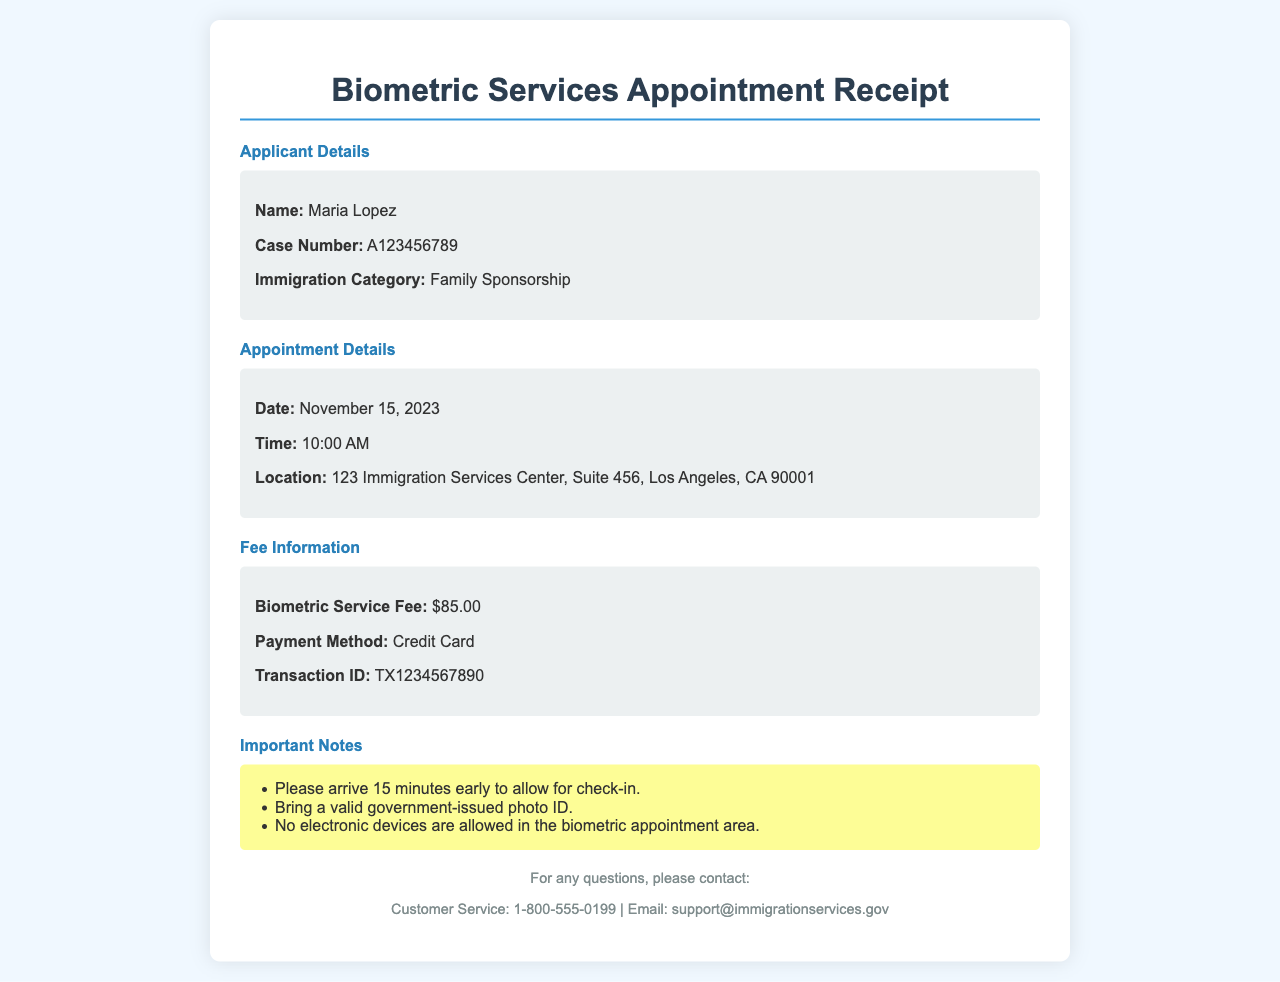What is the name of the applicant? The applicant's name is explicitly stated in the document under Applicant Details.
Answer: Maria Lopez When is the appointment date? The appointment date is clearly mentioned in the Appointment Details section.
Answer: November 15, 2023 What is the location of the biometric appointment? The location of the appointment is provided in the Appointment Details section, outlining where it will take place.
Answer: 123 Immigration Services Center, Suite 456, Los Angeles, CA 90001 How much is the biometric service fee? The fee for the biometric service is listed under Fee Information in the document.
Answer: $85.00 What is the payment method used? The payment method for the biometric service is indicated in the Fee Information section.
Answer: Credit Card What time is the appointment scheduled for? The scheduled time for the appointment can be found in the Appointment Details section.
Answer: 10:00 AM What is the transaction ID? The transaction ID is provided in the Fee Information section, useful for payment verification.
Answer: TX1234567890 How early should you arrive for the appointment? Guidelines for arrival time are listed in the Important Notes section.
Answer: 15 minutes early What should you bring to the appointment? Necessary items to bring for the appointment are specified in the Important Notes section.
Answer: Valid government-issued photo ID 